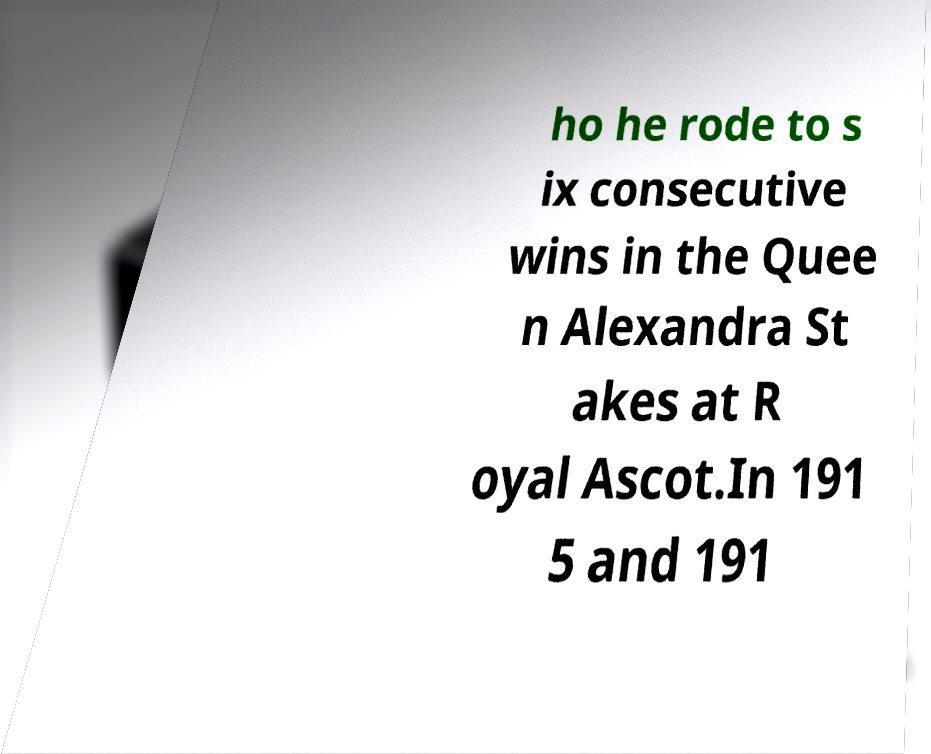I need the written content from this picture converted into text. Can you do that? ho he rode to s ix consecutive wins in the Quee n Alexandra St akes at R oyal Ascot.In 191 5 and 191 